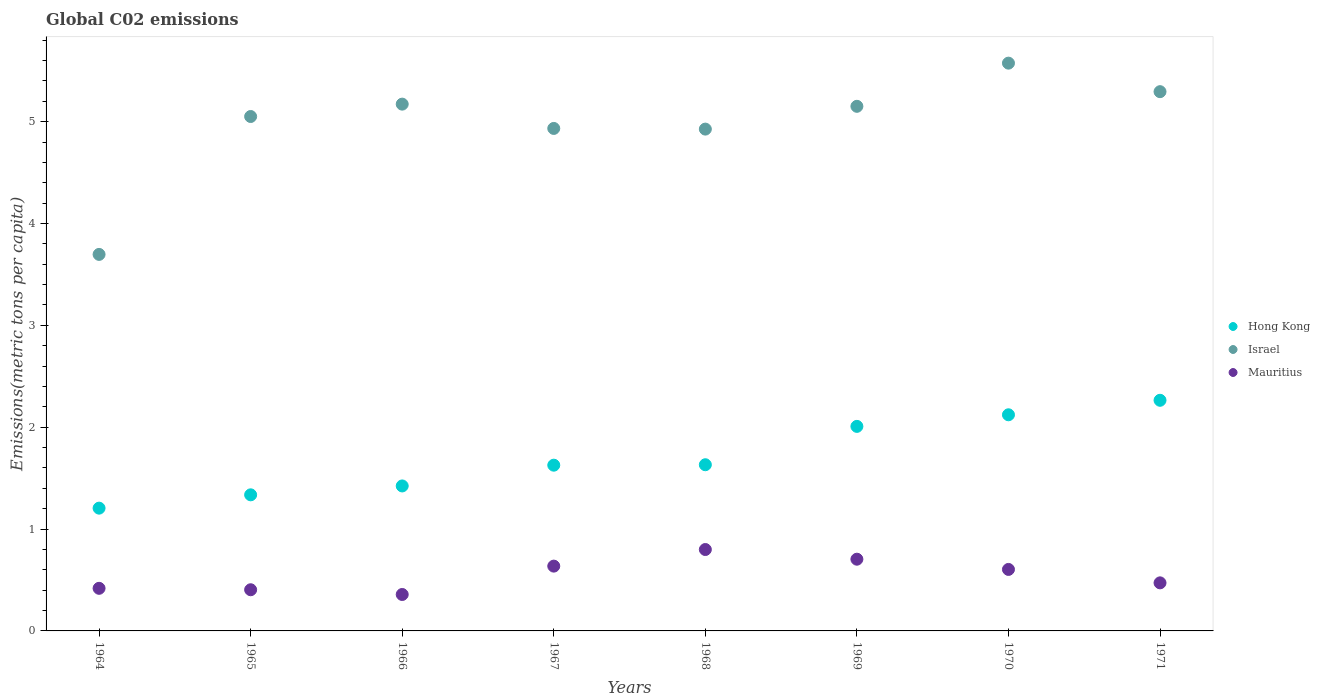How many different coloured dotlines are there?
Keep it short and to the point. 3. Is the number of dotlines equal to the number of legend labels?
Your response must be concise. Yes. What is the amount of CO2 emitted in in Mauritius in 1964?
Make the answer very short. 0.42. Across all years, what is the maximum amount of CO2 emitted in in Hong Kong?
Provide a succinct answer. 2.26. Across all years, what is the minimum amount of CO2 emitted in in Israel?
Offer a very short reply. 3.7. In which year was the amount of CO2 emitted in in Israel minimum?
Offer a terse response. 1964. What is the total amount of CO2 emitted in in Israel in the graph?
Offer a very short reply. 39.8. What is the difference between the amount of CO2 emitted in in Mauritius in 1969 and that in 1970?
Offer a very short reply. 0.1. What is the difference between the amount of CO2 emitted in in Hong Kong in 1966 and the amount of CO2 emitted in in Mauritius in 1971?
Provide a succinct answer. 0.95. What is the average amount of CO2 emitted in in Hong Kong per year?
Ensure brevity in your answer.  1.7. In the year 1968, what is the difference between the amount of CO2 emitted in in Mauritius and amount of CO2 emitted in in Hong Kong?
Your answer should be very brief. -0.83. What is the ratio of the amount of CO2 emitted in in Mauritius in 1968 to that in 1969?
Your answer should be very brief. 1.13. What is the difference between the highest and the second highest amount of CO2 emitted in in Mauritius?
Your response must be concise. 0.1. What is the difference between the highest and the lowest amount of CO2 emitted in in Israel?
Ensure brevity in your answer.  1.88. Is it the case that in every year, the sum of the amount of CO2 emitted in in Israel and amount of CO2 emitted in in Mauritius  is greater than the amount of CO2 emitted in in Hong Kong?
Provide a short and direct response. Yes. Does the amount of CO2 emitted in in Hong Kong monotonically increase over the years?
Offer a very short reply. Yes. Is the amount of CO2 emitted in in Mauritius strictly less than the amount of CO2 emitted in in Hong Kong over the years?
Keep it short and to the point. Yes. How many dotlines are there?
Your response must be concise. 3. How many years are there in the graph?
Keep it short and to the point. 8. Does the graph contain any zero values?
Your answer should be very brief. No. Does the graph contain grids?
Your answer should be very brief. No. Where does the legend appear in the graph?
Your response must be concise. Center right. How many legend labels are there?
Make the answer very short. 3. What is the title of the graph?
Offer a very short reply. Global C02 emissions. Does "Chad" appear as one of the legend labels in the graph?
Offer a very short reply. No. What is the label or title of the X-axis?
Your answer should be very brief. Years. What is the label or title of the Y-axis?
Your answer should be very brief. Emissions(metric tons per capita). What is the Emissions(metric tons per capita) of Hong Kong in 1964?
Your response must be concise. 1.21. What is the Emissions(metric tons per capita) in Israel in 1964?
Provide a succinct answer. 3.7. What is the Emissions(metric tons per capita) of Mauritius in 1964?
Provide a succinct answer. 0.42. What is the Emissions(metric tons per capita) of Hong Kong in 1965?
Your answer should be compact. 1.34. What is the Emissions(metric tons per capita) of Israel in 1965?
Offer a terse response. 5.05. What is the Emissions(metric tons per capita) in Mauritius in 1965?
Make the answer very short. 0.4. What is the Emissions(metric tons per capita) of Hong Kong in 1966?
Offer a very short reply. 1.42. What is the Emissions(metric tons per capita) of Israel in 1966?
Offer a terse response. 5.17. What is the Emissions(metric tons per capita) in Mauritius in 1966?
Offer a very short reply. 0.36. What is the Emissions(metric tons per capita) of Hong Kong in 1967?
Offer a terse response. 1.63. What is the Emissions(metric tons per capita) in Israel in 1967?
Ensure brevity in your answer.  4.93. What is the Emissions(metric tons per capita) in Mauritius in 1967?
Ensure brevity in your answer.  0.64. What is the Emissions(metric tons per capita) in Hong Kong in 1968?
Your answer should be compact. 1.63. What is the Emissions(metric tons per capita) of Israel in 1968?
Provide a short and direct response. 4.93. What is the Emissions(metric tons per capita) of Mauritius in 1968?
Keep it short and to the point. 0.8. What is the Emissions(metric tons per capita) of Hong Kong in 1969?
Offer a terse response. 2.01. What is the Emissions(metric tons per capita) of Israel in 1969?
Offer a very short reply. 5.15. What is the Emissions(metric tons per capita) in Mauritius in 1969?
Make the answer very short. 0.7. What is the Emissions(metric tons per capita) in Hong Kong in 1970?
Make the answer very short. 2.12. What is the Emissions(metric tons per capita) of Israel in 1970?
Ensure brevity in your answer.  5.57. What is the Emissions(metric tons per capita) in Mauritius in 1970?
Offer a terse response. 0.6. What is the Emissions(metric tons per capita) of Hong Kong in 1971?
Make the answer very short. 2.26. What is the Emissions(metric tons per capita) of Israel in 1971?
Keep it short and to the point. 5.29. What is the Emissions(metric tons per capita) in Mauritius in 1971?
Provide a short and direct response. 0.47. Across all years, what is the maximum Emissions(metric tons per capita) in Hong Kong?
Ensure brevity in your answer.  2.26. Across all years, what is the maximum Emissions(metric tons per capita) in Israel?
Provide a short and direct response. 5.57. Across all years, what is the maximum Emissions(metric tons per capita) of Mauritius?
Provide a short and direct response. 0.8. Across all years, what is the minimum Emissions(metric tons per capita) in Hong Kong?
Provide a short and direct response. 1.21. Across all years, what is the minimum Emissions(metric tons per capita) of Israel?
Provide a succinct answer. 3.7. Across all years, what is the minimum Emissions(metric tons per capita) in Mauritius?
Your answer should be very brief. 0.36. What is the total Emissions(metric tons per capita) of Hong Kong in the graph?
Your answer should be very brief. 13.62. What is the total Emissions(metric tons per capita) of Israel in the graph?
Ensure brevity in your answer.  39.8. What is the total Emissions(metric tons per capita) of Mauritius in the graph?
Provide a short and direct response. 4.4. What is the difference between the Emissions(metric tons per capita) in Hong Kong in 1964 and that in 1965?
Offer a terse response. -0.13. What is the difference between the Emissions(metric tons per capita) in Israel in 1964 and that in 1965?
Offer a very short reply. -1.35. What is the difference between the Emissions(metric tons per capita) of Mauritius in 1964 and that in 1965?
Your response must be concise. 0.01. What is the difference between the Emissions(metric tons per capita) of Hong Kong in 1964 and that in 1966?
Ensure brevity in your answer.  -0.22. What is the difference between the Emissions(metric tons per capita) of Israel in 1964 and that in 1966?
Keep it short and to the point. -1.48. What is the difference between the Emissions(metric tons per capita) in Mauritius in 1964 and that in 1966?
Your response must be concise. 0.06. What is the difference between the Emissions(metric tons per capita) in Hong Kong in 1964 and that in 1967?
Provide a short and direct response. -0.42. What is the difference between the Emissions(metric tons per capita) of Israel in 1964 and that in 1967?
Provide a short and direct response. -1.24. What is the difference between the Emissions(metric tons per capita) in Mauritius in 1964 and that in 1967?
Offer a terse response. -0.22. What is the difference between the Emissions(metric tons per capita) of Hong Kong in 1964 and that in 1968?
Give a very brief answer. -0.43. What is the difference between the Emissions(metric tons per capita) of Israel in 1964 and that in 1968?
Give a very brief answer. -1.23. What is the difference between the Emissions(metric tons per capita) in Mauritius in 1964 and that in 1968?
Offer a very short reply. -0.38. What is the difference between the Emissions(metric tons per capita) in Hong Kong in 1964 and that in 1969?
Your answer should be compact. -0.8. What is the difference between the Emissions(metric tons per capita) in Israel in 1964 and that in 1969?
Provide a short and direct response. -1.45. What is the difference between the Emissions(metric tons per capita) in Mauritius in 1964 and that in 1969?
Provide a succinct answer. -0.29. What is the difference between the Emissions(metric tons per capita) of Hong Kong in 1964 and that in 1970?
Your answer should be compact. -0.92. What is the difference between the Emissions(metric tons per capita) of Israel in 1964 and that in 1970?
Offer a very short reply. -1.88. What is the difference between the Emissions(metric tons per capita) of Mauritius in 1964 and that in 1970?
Your response must be concise. -0.19. What is the difference between the Emissions(metric tons per capita) of Hong Kong in 1964 and that in 1971?
Provide a short and direct response. -1.06. What is the difference between the Emissions(metric tons per capita) of Israel in 1964 and that in 1971?
Ensure brevity in your answer.  -1.6. What is the difference between the Emissions(metric tons per capita) of Mauritius in 1964 and that in 1971?
Make the answer very short. -0.05. What is the difference between the Emissions(metric tons per capita) in Hong Kong in 1965 and that in 1966?
Ensure brevity in your answer.  -0.09. What is the difference between the Emissions(metric tons per capita) of Israel in 1965 and that in 1966?
Provide a succinct answer. -0.12. What is the difference between the Emissions(metric tons per capita) of Mauritius in 1965 and that in 1966?
Offer a terse response. 0.05. What is the difference between the Emissions(metric tons per capita) in Hong Kong in 1965 and that in 1967?
Offer a terse response. -0.29. What is the difference between the Emissions(metric tons per capita) in Israel in 1965 and that in 1967?
Your response must be concise. 0.12. What is the difference between the Emissions(metric tons per capita) in Mauritius in 1965 and that in 1967?
Provide a short and direct response. -0.23. What is the difference between the Emissions(metric tons per capita) of Hong Kong in 1965 and that in 1968?
Offer a very short reply. -0.3. What is the difference between the Emissions(metric tons per capita) of Israel in 1965 and that in 1968?
Make the answer very short. 0.12. What is the difference between the Emissions(metric tons per capita) of Mauritius in 1965 and that in 1968?
Your answer should be compact. -0.4. What is the difference between the Emissions(metric tons per capita) of Hong Kong in 1965 and that in 1969?
Give a very brief answer. -0.67. What is the difference between the Emissions(metric tons per capita) in Israel in 1965 and that in 1969?
Give a very brief answer. -0.1. What is the difference between the Emissions(metric tons per capita) of Mauritius in 1965 and that in 1969?
Make the answer very short. -0.3. What is the difference between the Emissions(metric tons per capita) of Hong Kong in 1965 and that in 1970?
Give a very brief answer. -0.79. What is the difference between the Emissions(metric tons per capita) of Israel in 1965 and that in 1970?
Offer a terse response. -0.52. What is the difference between the Emissions(metric tons per capita) in Mauritius in 1965 and that in 1970?
Ensure brevity in your answer.  -0.2. What is the difference between the Emissions(metric tons per capita) of Hong Kong in 1965 and that in 1971?
Your answer should be very brief. -0.93. What is the difference between the Emissions(metric tons per capita) in Israel in 1965 and that in 1971?
Offer a terse response. -0.24. What is the difference between the Emissions(metric tons per capita) of Mauritius in 1965 and that in 1971?
Offer a very short reply. -0.07. What is the difference between the Emissions(metric tons per capita) of Hong Kong in 1966 and that in 1967?
Keep it short and to the point. -0.2. What is the difference between the Emissions(metric tons per capita) in Israel in 1966 and that in 1967?
Provide a succinct answer. 0.24. What is the difference between the Emissions(metric tons per capita) in Mauritius in 1966 and that in 1967?
Offer a very short reply. -0.28. What is the difference between the Emissions(metric tons per capita) in Hong Kong in 1966 and that in 1968?
Keep it short and to the point. -0.21. What is the difference between the Emissions(metric tons per capita) in Israel in 1966 and that in 1968?
Your response must be concise. 0.25. What is the difference between the Emissions(metric tons per capita) of Mauritius in 1966 and that in 1968?
Provide a short and direct response. -0.44. What is the difference between the Emissions(metric tons per capita) of Hong Kong in 1966 and that in 1969?
Your response must be concise. -0.58. What is the difference between the Emissions(metric tons per capita) of Israel in 1966 and that in 1969?
Provide a succinct answer. 0.02. What is the difference between the Emissions(metric tons per capita) in Mauritius in 1966 and that in 1969?
Offer a terse response. -0.35. What is the difference between the Emissions(metric tons per capita) of Hong Kong in 1966 and that in 1970?
Make the answer very short. -0.7. What is the difference between the Emissions(metric tons per capita) in Israel in 1966 and that in 1970?
Offer a very short reply. -0.4. What is the difference between the Emissions(metric tons per capita) of Mauritius in 1966 and that in 1970?
Make the answer very short. -0.25. What is the difference between the Emissions(metric tons per capita) of Hong Kong in 1966 and that in 1971?
Provide a succinct answer. -0.84. What is the difference between the Emissions(metric tons per capita) in Israel in 1966 and that in 1971?
Provide a succinct answer. -0.12. What is the difference between the Emissions(metric tons per capita) of Mauritius in 1966 and that in 1971?
Your answer should be compact. -0.11. What is the difference between the Emissions(metric tons per capita) of Hong Kong in 1967 and that in 1968?
Your answer should be very brief. -0. What is the difference between the Emissions(metric tons per capita) in Israel in 1967 and that in 1968?
Your answer should be compact. 0.01. What is the difference between the Emissions(metric tons per capita) in Mauritius in 1967 and that in 1968?
Your answer should be compact. -0.16. What is the difference between the Emissions(metric tons per capita) of Hong Kong in 1967 and that in 1969?
Give a very brief answer. -0.38. What is the difference between the Emissions(metric tons per capita) of Israel in 1967 and that in 1969?
Offer a very short reply. -0.22. What is the difference between the Emissions(metric tons per capita) in Mauritius in 1967 and that in 1969?
Offer a very short reply. -0.07. What is the difference between the Emissions(metric tons per capita) in Hong Kong in 1967 and that in 1970?
Provide a succinct answer. -0.49. What is the difference between the Emissions(metric tons per capita) of Israel in 1967 and that in 1970?
Your response must be concise. -0.64. What is the difference between the Emissions(metric tons per capita) of Mauritius in 1967 and that in 1970?
Make the answer very short. 0.03. What is the difference between the Emissions(metric tons per capita) of Hong Kong in 1967 and that in 1971?
Make the answer very short. -0.64. What is the difference between the Emissions(metric tons per capita) in Israel in 1967 and that in 1971?
Your answer should be compact. -0.36. What is the difference between the Emissions(metric tons per capita) of Mauritius in 1967 and that in 1971?
Provide a succinct answer. 0.16. What is the difference between the Emissions(metric tons per capita) in Hong Kong in 1968 and that in 1969?
Offer a terse response. -0.38. What is the difference between the Emissions(metric tons per capita) in Israel in 1968 and that in 1969?
Provide a short and direct response. -0.22. What is the difference between the Emissions(metric tons per capita) in Mauritius in 1968 and that in 1969?
Provide a short and direct response. 0.1. What is the difference between the Emissions(metric tons per capita) in Hong Kong in 1968 and that in 1970?
Your answer should be compact. -0.49. What is the difference between the Emissions(metric tons per capita) in Israel in 1968 and that in 1970?
Give a very brief answer. -0.65. What is the difference between the Emissions(metric tons per capita) of Mauritius in 1968 and that in 1970?
Keep it short and to the point. 0.2. What is the difference between the Emissions(metric tons per capita) in Hong Kong in 1968 and that in 1971?
Make the answer very short. -0.63. What is the difference between the Emissions(metric tons per capita) in Israel in 1968 and that in 1971?
Your answer should be very brief. -0.37. What is the difference between the Emissions(metric tons per capita) of Mauritius in 1968 and that in 1971?
Ensure brevity in your answer.  0.33. What is the difference between the Emissions(metric tons per capita) of Hong Kong in 1969 and that in 1970?
Ensure brevity in your answer.  -0.11. What is the difference between the Emissions(metric tons per capita) in Israel in 1969 and that in 1970?
Your response must be concise. -0.42. What is the difference between the Emissions(metric tons per capita) of Mauritius in 1969 and that in 1970?
Your answer should be very brief. 0.1. What is the difference between the Emissions(metric tons per capita) of Hong Kong in 1969 and that in 1971?
Offer a terse response. -0.26. What is the difference between the Emissions(metric tons per capita) in Israel in 1969 and that in 1971?
Make the answer very short. -0.14. What is the difference between the Emissions(metric tons per capita) of Mauritius in 1969 and that in 1971?
Offer a very short reply. 0.23. What is the difference between the Emissions(metric tons per capita) in Hong Kong in 1970 and that in 1971?
Offer a very short reply. -0.14. What is the difference between the Emissions(metric tons per capita) in Israel in 1970 and that in 1971?
Give a very brief answer. 0.28. What is the difference between the Emissions(metric tons per capita) in Mauritius in 1970 and that in 1971?
Offer a terse response. 0.13. What is the difference between the Emissions(metric tons per capita) of Hong Kong in 1964 and the Emissions(metric tons per capita) of Israel in 1965?
Your response must be concise. -3.85. What is the difference between the Emissions(metric tons per capita) of Hong Kong in 1964 and the Emissions(metric tons per capita) of Mauritius in 1965?
Provide a succinct answer. 0.8. What is the difference between the Emissions(metric tons per capita) of Israel in 1964 and the Emissions(metric tons per capita) of Mauritius in 1965?
Make the answer very short. 3.29. What is the difference between the Emissions(metric tons per capita) of Hong Kong in 1964 and the Emissions(metric tons per capita) of Israel in 1966?
Provide a short and direct response. -3.97. What is the difference between the Emissions(metric tons per capita) in Hong Kong in 1964 and the Emissions(metric tons per capita) in Mauritius in 1966?
Provide a succinct answer. 0.85. What is the difference between the Emissions(metric tons per capita) in Israel in 1964 and the Emissions(metric tons per capita) in Mauritius in 1966?
Your response must be concise. 3.34. What is the difference between the Emissions(metric tons per capita) of Hong Kong in 1964 and the Emissions(metric tons per capita) of Israel in 1967?
Your response must be concise. -3.73. What is the difference between the Emissions(metric tons per capita) of Hong Kong in 1964 and the Emissions(metric tons per capita) of Mauritius in 1967?
Provide a short and direct response. 0.57. What is the difference between the Emissions(metric tons per capita) in Israel in 1964 and the Emissions(metric tons per capita) in Mauritius in 1967?
Offer a terse response. 3.06. What is the difference between the Emissions(metric tons per capita) in Hong Kong in 1964 and the Emissions(metric tons per capita) in Israel in 1968?
Offer a very short reply. -3.72. What is the difference between the Emissions(metric tons per capita) in Hong Kong in 1964 and the Emissions(metric tons per capita) in Mauritius in 1968?
Ensure brevity in your answer.  0.41. What is the difference between the Emissions(metric tons per capita) in Israel in 1964 and the Emissions(metric tons per capita) in Mauritius in 1968?
Make the answer very short. 2.9. What is the difference between the Emissions(metric tons per capita) of Hong Kong in 1964 and the Emissions(metric tons per capita) of Israel in 1969?
Give a very brief answer. -3.95. What is the difference between the Emissions(metric tons per capita) of Hong Kong in 1964 and the Emissions(metric tons per capita) of Mauritius in 1969?
Give a very brief answer. 0.5. What is the difference between the Emissions(metric tons per capita) in Israel in 1964 and the Emissions(metric tons per capita) in Mauritius in 1969?
Make the answer very short. 2.99. What is the difference between the Emissions(metric tons per capita) in Hong Kong in 1964 and the Emissions(metric tons per capita) in Israel in 1970?
Your response must be concise. -4.37. What is the difference between the Emissions(metric tons per capita) in Hong Kong in 1964 and the Emissions(metric tons per capita) in Mauritius in 1970?
Keep it short and to the point. 0.6. What is the difference between the Emissions(metric tons per capita) of Israel in 1964 and the Emissions(metric tons per capita) of Mauritius in 1970?
Make the answer very short. 3.09. What is the difference between the Emissions(metric tons per capita) in Hong Kong in 1964 and the Emissions(metric tons per capita) in Israel in 1971?
Ensure brevity in your answer.  -4.09. What is the difference between the Emissions(metric tons per capita) of Hong Kong in 1964 and the Emissions(metric tons per capita) of Mauritius in 1971?
Make the answer very short. 0.73. What is the difference between the Emissions(metric tons per capita) of Israel in 1964 and the Emissions(metric tons per capita) of Mauritius in 1971?
Provide a succinct answer. 3.22. What is the difference between the Emissions(metric tons per capita) in Hong Kong in 1965 and the Emissions(metric tons per capita) in Israel in 1966?
Offer a very short reply. -3.84. What is the difference between the Emissions(metric tons per capita) of Hong Kong in 1965 and the Emissions(metric tons per capita) of Mauritius in 1966?
Provide a succinct answer. 0.98. What is the difference between the Emissions(metric tons per capita) of Israel in 1965 and the Emissions(metric tons per capita) of Mauritius in 1966?
Make the answer very short. 4.69. What is the difference between the Emissions(metric tons per capita) of Hong Kong in 1965 and the Emissions(metric tons per capita) of Israel in 1967?
Provide a short and direct response. -3.6. What is the difference between the Emissions(metric tons per capita) of Israel in 1965 and the Emissions(metric tons per capita) of Mauritius in 1967?
Provide a short and direct response. 4.41. What is the difference between the Emissions(metric tons per capita) of Hong Kong in 1965 and the Emissions(metric tons per capita) of Israel in 1968?
Your answer should be very brief. -3.59. What is the difference between the Emissions(metric tons per capita) in Hong Kong in 1965 and the Emissions(metric tons per capita) in Mauritius in 1968?
Make the answer very short. 0.54. What is the difference between the Emissions(metric tons per capita) of Israel in 1965 and the Emissions(metric tons per capita) of Mauritius in 1968?
Give a very brief answer. 4.25. What is the difference between the Emissions(metric tons per capita) in Hong Kong in 1965 and the Emissions(metric tons per capita) in Israel in 1969?
Provide a short and direct response. -3.81. What is the difference between the Emissions(metric tons per capita) in Hong Kong in 1965 and the Emissions(metric tons per capita) in Mauritius in 1969?
Make the answer very short. 0.63. What is the difference between the Emissions(metric tons per capita) of Israel in 1965 and the Emissions(metric tons per capita) of Mauritius in 1969?
Provide a short and direct response. 4.35. What is the difference between the Emissions(metric tons per capita) of Hong Kong in 1965 and the Emissions(metric tons per capita) of Israel in 1970?
Offer a terse response. -4.24. What is the difference between the Emissions(metric tons per capita) in Hong Kong in 1965 and the Emissions(metric tons per capita) in Mauritius in 1970?
Your answer should be very brief. 0.73. What is the difference between the Emissions(metric tons per capita) in Israel in 1965 and the Emissions(metric tons per capita) in Mauritius in 1970?
Offer a very short reply. 4.45. What is the difference between the Emissions(metric tons per capita) in Hong Kong in 1965 and the Emissions(metric tons per capita) in Israel in 1971?
Provide a short and direct response. -3.96. What is the difference between the Emissions(metric tons per capita) of Hong Kong in 1965 and the Emissions(metric tons per capita) of Mauritius in 1971?
Your response must be concise. 0.86. What is the difference between the Emissions(metric tons per capita) in Israel in 1965 and the Emissions(metric tons per capita) in Mauritius in 1971?
Your answer should be compact. 4.58. What is the difference between the Emissions(metric tons per capita) of Hong Kong in 1966 and the Emissions(metric tons per capita) of Israel in 1967?
Provide a succinct answer. -3.51. What is the difference between the Emissions(metric tons per capita) of Hong Kong in 1966 and the Emissions(metric tons per capita) of Mauritius in 1967?
Your answer should be very brief. 0.79. What is the difference between the Emissions(metric tons per capita) of Israel in 1966 and the Emissions(metric tons per capita) of Mauritius in 1967?
Provide a short and direct response. 4.54. What is the difference between the Emissions(metric tons per capita) of Hong Kong in 1966 and the Emissions(metric tons per capita) of Israel in 1968?
Give a very brief answer. -3.5. What is the difference between the Emissions(metric tons per capita) of Hong Kong in 1966 and the Emissions(metric tons per capita) of Mauritius in 1968?
Keep it short and to the point. 0.62. What is the difference between the Emissions(metric tons per capita) in Israel in 1966 and the Emissions(metric tons per capita) in Mauritius in 1968?
Offer a very short reply. 4.37. What is the difference between the Emissions(metric tons per capita) in Hong Kong in 1966 and the Emissions(metric tons per capita) in Israel in 1969?
Offer a very short reply. -3.73. What is the difference between the Emissions(metric tons per capita) of Hong Kong in 1966 and the Emissions(metric tons per capita) of Mauritius in 1969?
Give a very brief answer. 0.72. What is the difference between the Emissions(metric tons per capita) of Israel in 1966 and the Emissions(metric tons per capita) of Mauritius in 1969?
Your response must be concise. 4.47. What is the difference between the Emissions(metric tons per capita) in Hong Kong in 1966 and the Emissions(metric tons per capita) in Israel in 1970?
Your answer should be compact. -4.15. What is the difference between the Emissions(metric tons per capita) of Hong Kong in 1966 and the Emissions(metric tons per capita) of Mauritius in 1970?
Offer a terse response. 0.82. What is the difference between the Emissions(metric tons per capita) of Israel in 1966 and the Emissions(metric tons per capita) of Mauritius in 1970?
Ensure brevity in your answer.  4.57. What is the difference between the Emissions(metric tons per capita) in Hong Kong in 1966 and the Emissions(metric tons per capita) in Israel in 1971?
Give a very brief answer. -3.87. What is the difference between the Emissions(metric tons per capita) of Hong Kong in 1966 and the Emissions(metric tons per capita) of Mauritius in 1971?
Provide a short and direct response. 0.95. What is the difference between the Emissions(metric tons per capita) of Israel in 1966 and the Emissions(metric tons per capita) of Mauritius in 1971?
Offer a very short reply. 4.7. What is the difference between the Emissions(metric tons per capita) in Hong Kong in 1967 and the Emissions(metric tons per capita) in Israel in 1968?
Offer a terse response. -3.3. What is the difference between the Emissions(metric tons per capita) in Hong Kong in 1967 and the Emissions(metric tons per capita) in Mauritius in 1968?
Give a very brief answer. 0.83. What is the difference between the Emissions(metric tons per capita) of Israel in 1967 and the Emissions(metric tons per capita) of Mauritius in 1968?
Give a very brief answer. 4.13. What is the difference between the Emissions(metric tons per capita) in Hong Kong in 1967 and the Emissions(metric tons per capita) in Israel in 1969?
Give a very brief answer. -3.52. What is the difference between the Emissions(metric tons per capita) of Hong Kong in 1967 and the Emissions(metric tons per capita) of Mauritius in 1969?
Your answer should be very brief. 0.92. What is the difference between the Emissions(metric tons per capita) in Israel in 1967 and the Emissions(metric tons per capita) in Mauritius in 1969?
Make the answer very short. 4.23. What is the difference between the Emissions(metric tons per capita) in Hong Kong in 1967 and the Emissions(metric tons per capita) in Israel in 1970?
Keep it short and to the point. -3.95. What is the difference between the Emissions(metric tons per capita) of Hong Kong in 1967 and the Emissions(metric tons per capita) of Mauritius in 1970?
Provide a succinct answer. 1.02. What is the difference between the Emissions(metric tons per capita) in Israel in 1967 and the Emissions(metric tons per capita) in Mauritius in 1970?
Keep it short and to the point. 4.33. What is the difference between the Emissions(metric tons per capita) in Hong Kong in 1967 and the Emissions(metric tons per capita) in Israel in 1971?
Offer a terse response. -3.67. What is the difference between the Emissions(metric tons per capita) of Hong Kong in 1967 and the Emissions(metric tons per capita) of Mauritius in 1971?
Provide a succinct answer. 1.16. What is the difference between the Emissions(metric tons per capita) of Israel in 1967 and the Emissions(metric tons per capita) of Mauritius in 1971?
Keep it short and to the point. 4.46. What is the difference between the Emissions(metric tons per capita) in Hong Kong in 1968 and the Emissions(metric tons per capita) in Israel in 1969?
Give a very brief answer. -3.52. What is the difference between the Emissions(metric tons per capita) of Hong Kong in 1968 and the Emissions(metric tons per capita) of Mauritius in 1969?
Your response must be concise. 0.93. What is the difference between the Emissions(metric tons per capita) of Israel in 1968 and the Emissions(metric tons per capita) of Mauritius in 1969?
Your answer should be compact. 4.22. What is the difference between the Emissions(metric tons per capita) in Hong Kong in 1968 and the Emissions(metric tons per capita) in Israel in 1970?
Keep it short and to the point. -3.94. What is the difference between the Emissions(metric tons per capita) of Hong Kong in 1968 and the Emissions(metric tons per capita) of Mauritius in 1970?
Ensure brevity in your answer.  1.03. What is the difference between the Emissions(metric tons per capita) of Israel in 1968 and the Emissions(metric tons per capita) of Mauritius in 1970?
Ensure brevity in your answer.  4.32. What is the difference between the Emissions(metric tons per capita) in Hong Kong in 1968 and the Emissions(metric tons per capita) in Israel in 1971?
Provide a short and direct response. -3.66. What is the difference between the Emissions(metric tons per capita) in Hong Kong in 1968 and the Emissions(metric tons per capita) in Mauritius in 1971?
Offer a very short reply. 1.16. What is the difference between the Emissions(metric tons per capita) in Israel in 1968 and the Emissions(metric tons per capita) in Mauritius in 1971?
Your response must be concise. 4.45. What is the difference between the Emissions(metric tons per capita) of Hong Kong in 1969 and the Emissions(metric tons per capita) of Israel in 1970?
Ensure brevity in your answer.  -3.57. What is the difference between the Emissions(metric tons per capita) of Hong Kong in 1969 and the Emissions(metric tons per capita) of Mauritius in 1970?
Provide a short and direct response. 1.4. What is the difference between the Emissions(metric tons per capita) of Israel in 1969 and the Emissions(metric tons per capita) of Mauritius in 1970?
Ensure brevity in your answer.  4.55. What is the difference between the Emissions(metric tons per capita) in Hong Kong in 1969 and the Emissions(metric tons per capita) in Israel in 1971?
Offer a very short reply. -3.29. What is the difference between the Emissions(metric tons per capita) in Hong Kong in 1969 and the Emissions(metric tons per capita) in Mauritius in 1971?
Offer a terse response. 1.54. What is the difference between the Emissions(metric tons per capita) in Israel in 1969 and the Emissions(metric tons per capita) in Mauritius in 1971?
Ensure brevity in your answer.  4.68. What is the difference between the Emissions(metric tons per capita) of Hong Kong in 1970 and the Emissions(metric tons per capita) of Israel in 1971?
Ensure brevity in your answer.  -3.17. What is the difference between the Emissions(metric tons per capita) in Hong Kong in 1970 and the Emissions(metric tons per capita) in Mauritius in 1971?
Your answer should be very brief. 1.65. What is the difference between the Emissions(metric tons per capita) of Israel in 1970 and the Emissions(metric tons per capita) of Mauritius in 1971?
Keep it short and to the point. 5.1. What is the average Emissions(metric tons per capita) of Hong Kong per year?
Give a very brief answer. 1.7. What is the average Emissions(metric tons per capita) of Israel per year?
Keep it short and to the point. 4.97. What is the average Emissions(metric tons per capita) of Mauritius per year?
Your response must be concise. 0.55. In the year 1964, what is the difference between the Emissions(metric tons per capita) of Hong Kong and Emissions(metric tons per capita) of Israel?
Ensure brevity in your answer.  -2.49. In the year 1964, what is the difference between the Emissions(metric tons per capita) of Hong Kong and Emissions(metric tons per capita) of Mauritius?
Make the answer very short. 0.79. In the year 1964, what is the difference between the Emissions(metric tons per capita) in Israel and Emissions(metric tons per capita) in Mauritius?
Offer a terse response. 3.28. In the year 1965, what is the difference between the Emissions(metric tons per capita) of Hong Kong and Emissions(metric tons per capita) of Israel?
Ensure brevity in your answer.  -3.71. In the year 1965, what is the difference between the Emissions(metric tons per capita) of Hong Kong and Emissions(metric tons per capita) of Mauritius?
Ensure brevity in your answer.  0.93. In the year 1965, what is the difference between the Emissions(metric tons per capita) of Israel and Emissions(metric tons per capita) of Mauritius?
Your answer should be very brief. 4.65. In the year 1966, what is the difference between the Emissions(metric tons per capita) in Hong Kong and Emissions(metric tons per capita) in Israel?
Provide a succinct answer. -3.75. In the year 1966, what is the difference between the Emissions(metric tons per capita) of Hong Kong and Emissions(metric tons per capita) of Mauritius?
Your answer should be compact. 1.07. In the year 1966, what is the difference between the Emissions(metric tons per capita) in Israel and Emissions(metric tons per capita) in Mauritius?
Provide a succinct answer. 4.81. In the year 1967, what is the difference between the Emissions(metric tons per capita) of Hong Kong and Emissions(metric tons per capita) of Israel?
Your response must be concise. -3.31. In the year 1967, what is the difference between the Emissions(metric tons per capita) of Israel and Emissions(metric tons per capita) of Mauritius?
Make the answer very short. 4.3. In the year 1968, what is the difference between the Emissions(metric tons per capita) of Hong Kong and Emissions(metric tons per capita) of Israel?
Offer a terse response. -3.3. In the year 1968, what is the difference between the Emissions(metric tons per capita) in Hong Kong and Emissions(metric tons per capita) in Mauritius?
Offer a very short reply. 0.83. In the year 1968, what is the difference between the Emissions(metric tons per capita) of Israel and Emissions(metric tons per capita) of Mauritius?
Give a very brief answer. 4.13. In the year 1969, what is the difference between the Emissions(metric tons per capita) of Hong Kong and Emissions(metric tons per capita) of Israel?
Your response must be concise. -3.14. In the year 1969, what is the difference between the Emissions(metric tons per capita) in Hong Kong and Emissions(metric tons per capita) in Mauritius?
Provide a short and direct response. 1.3. In the year 1969, what is the difference between the Emissions(metric tons per capita) of Israel and Emissions(metric tons per capita) of Mauritius?
Your answer should be compact. 4.45. In the year 1970, what is the difference between the Emissions(metric tons per capita) of Hong Kong and Emissions(metric tons per capita) of Israel?
Make the answer very short. -3.45. In the year 1970, what is the difference between the Emissions(metric tons per capita) in Hong Kong and Emissions(metric tons per capita) in Mauritius?
Keep it short and to the point. 1.52. In the year 1970, what is the difference between the Emissions(metric tons per capita) in Israel and Emissions(metric tons per capita) in Mauritius?
Offer a very short reply. 4.97. In the year 1971, what is the difference between the Emissions(metric tons per capita) of Hong Kong and Emissions(metric tons per capita) of Israel?
Offer a terse response. -3.03. In the year 1971, what is the difference between the Emissions(metric tons per capita) in Hong Kong and Emissions(metric tons per capita) in Mauritius?
Keep it short and to the point. 1.79. In the year 1971, what is the difference between the Emissions(metric tons per capita) in Israel and Emissions(metric tons per capita) in Mauritius?
Make the answer very short. 4.82. What is the ratio of the Emissions(metric tons per capita) of Hong Kong in 1964 to that in 1965?
Your answer should be compact. 0.9. What is the ratio of the Emissions(metric tons per capita) of Israel in 1964 to that in 1965?
Provide a succinct answer. 0.73. What is the ratio of the Emissions(metric tons per capita) in Mauritius in 1964 to that in 1965?
Provide a succinct answer. 1.03. What is the ratio of the Emissions(metric tons per capita) in Hong Kong in 1964 to that in 1966?
Offer a terse response. 0.85. What is the ratio of the Emissions(metric tons per capita) of Israel in 1964 to that in 1966?
Ensure brevity in your answer.  0.71. What is the ratio of the Emissions(metric tons per capita) of Mauritius in 1964 to that in 1966?
Keep it short and to the point. 1.17. What is the ratio of the Emissions(metric tons per capita) of Hong Kong in 1964 to that in 1967?
Provide a succinct answer. 0.74. What is the ratio of the Emissions(metric tons per capita) of Israel in 1964 to that in 1967?
Offer a terse response. 0.75. What is the ratio of the Emissions(metric tons per capita) of Mauritius in 1964 to that in 1967?
Ensure brevity in your answer.  0.66. What is the ratio of the Emissions(metric tons per capita) of Hong Kong in 1964 to that in 1968?
Your answer should be compact. 0.74. What is the ratio of the Emissions(metric tons per capita) in Israel in 1964 to that in 1968?
Your answer should be compact. 0.75. What is the ratio of the Emissions(metric tons per capita) in Mauritius in 1964 to that in 1968?
Your response must be concise. 0.52. What is the ratio of the Emissions(metric tons per capita) of Hong Kong in 1964 to that in 1969?
Your answer should be very brief. 0.6. What is the ratio of the Emissions(metric tons per capita) of Israel in 1964 to that in 1969?
Make the answer very short. 0.72. What is the ratio of the Emissions(metric tons per capita) of Mauritius in 1964 to that in 1969?
Make the answer very short. 0.59. What is the ratio of the Emissions(metric tons per capita) in Hong Kong in 1964 to that in 1970?
Offer a terse response. 0.57. What is the ratio of the Emissions(metric tons per capita) in Israel in 1964 to that in 1970?
Offer a very short reply. 0.66. What is the ratio of the Emissions(metric tons per capita) in Mauritius in 1964 to that in 1970?
Your response must be concise. 0.69. What is the ratio of the Emissions(metric tons per capita) of Hong Kong in 1964 to that in 1971?
Ensure brevity in your answer.  0.53. What is the ratio of the Emissions(metric tons per capita) in Israel in 1964 to that in 1971?
Provide a short and direct response. 0.7. What is the ratio of the Emissions(metric tons per capita) in Mauritius in 1964 to that in 1971?
Your answer should be very brief. 0.89. What is the ratio of the Emissions(metric tons per capita) in Hong Kong in 1965 to that in 1966?
Your answer should be very brief. 0.94. What is the ratio of the Emissions(metric tons per capita) of Israel in 1965 to that in 1966?
Offer a terse response. 0.98. What is the ratio of the Emissions(metric tons per capita) in Mauritius in 1965 to that in 1966?
Your answer should be very brief. 1.13. What is the ratio of the Emissions(metric tons per capita) in Hong Kong in 1965 to that in 1967?
Keep it short and to the point. 0.82. What is the ratio of the Emissions(metric tons per capita) of Israel in 1965 to that in 1967?
Offer a very short reply. 1.02. What is the ratio of the Emissions(metric tons per capita) in Mauritius in 1965 to that in 1967?
Provide a succinct answer. 0.64. What is the ratio of the Emissions(metric tons per capita) in Hong Kong in 1965 to that in 1968?
Your answer should be compact. 0.82. What is the ratio of the Emissions(metric tons per capita) of Israel in 1965 to that in 1968?
Offer a terse response. 1.03. What is the ratio of the Emissions(metric tons per capita) in Mauritius in 1965 to that in 1968?
Make the answer very short. 0.51. What is the ratio of the Emissions(metric tons per capita) of Hong Kong in 1965 to that in 1969?
Your answer should be compact. 0.67. What is the ratio of the Emissions(metric tons per capita) in Israel in 1965 to that in 1969?
Offer a terse response. 0.98. What is the ratio of the Emissions(metric tons per capita) in Mauritius in 1965 to that in 1969?
Your answer should be compact. 0.57. What is the ratio of the Emissions(metric tons per capita) in Hong Kong in 1965 to that in 1970?
Give a very brief answer. 0.63. What is the ratio of the Emissions(metric tons per capita) of Israel in 1965 to that in 1970?
Ensure brevity in your answer.  0.91. What is the ratio of the Emissions(metric tons per capita) in Mauritius in 1965 to that in 1970?
Your answer should be very brief. 0.67. What is the ratio of the Emissions(metric tons per capita) of Hong Kong in 1965 to that in 1971?
Make the answer very short. 0.59. What is the ratio of the Emissions(metric tons per capita) of Israel in 1965 to that in 1971?
Ensure brevity in your answer.  0.95. What is the ratio of the Emissions(metric tons per capita) of Mauritius in 1965 to that in 1971?
Give a very brief answer. 0.86. What is the ratio of the Emissions(metric tons per capita) of Hong Kong in 1966 to that in 1967?
Keep it short and to the point. 0.87. What is the ratio of the Emissions(metric tons per capita) in Israel in 1966 to that in 1967?
Give a very brief answer. 1.05. What is the ratio of the Emissions(metric tons per capita) in Mauritius in 1966 to that in 1967?
Keep it short and to the point. 0.56. What is the ratio of the Emissions(metric tons per capita) of Hong Kong in 1966 to that in 1968?
Your response must be concise. 0.87. What is the ratio of the Emissions(metric tons per capita) of Israel in 1966 to that in 1968?
Your response must be concise. 1.05. What is the ratio of the Emissions(metric tons per capita) in Mauritius in 1966 to that in 1968?
Make the answer very short. 0.45. What is the ratio of the Emissions(metric tons per capita) in Hong Kong in 1966 to that in 1969?
Offer a terse response. 0.71. What is the ratio of the Emissions(metric tons per capita) of Israel in 1966 to that in 1969?
Ensure brevity in your answer.  1. What is the ratio of the Emissions(metric tons per capita) in Mauritius in 1966 to that in 1969?
Your answer should be very brief. 0.51. What is the ratio of the Emissions(metric tons per capita) of Hong Kong in 1966 to that in 1970?
Your answer should be very brief. 0.67. What is the ratio of the Emissions(metric tons per capita) in Israel in 1966 to that in 1970?
Offer a very short reply. 0.93. What is the ratio of the Emissions(metric tons per capita) in Mauritius in 1966 to that in 1970?
Your answer should be compact. 0.59. What is the ratio of the Emissions(metric tons per capita) of Hong Kong in 1966 to that in 1971?
Offer a terse response. 0.63. What is the ratio of the Emissions(metric tons per capita) of Israel in 1966 to that in 1971?
Offer a terse response. 0.98. What is the ratio of the Emissions(metric tons per capita) of Mauritius in 1966 to that in 1971?
Your answer should be very brief. 0.76. What is the ratio of the Emissions(metric tons per capita) in Mauritius in 1967 to that in 1968?
Offer a very short reply. 0.8. What is the ratio of the Emissions(metric tons per capita) in Hong Kong in 1967 to that in 1969?
Give a very brief answer. 0.81. What is the ratio of the Emissions(metric tons per capita) in Israel in 1967 to that in 1969?
Offer a very short reply. 0.96. What is the ratio of the Emissions(metric tons per capita) of Mauritius in 1967 to that in 1969?
Provide a succinct answer. 0.9. What is the ratio of the Emissions(metric tons per capita) of Hong Kong in 1967 to that in 1970?
Ensure brevity in your answer.  0.77. What is the ratio of the Emissions(metric tons per capita) of Israel in 1967 to that in 1970?
Your answer should be very brief. 0.89. What is the ratio of the Emissions(metric tons per capita) of Mauritius in 1967 to that in 1970?
Provide a short and direct response. 1.05. What is the ratio of the Emissions(metric tons per capita) in Hong Kong in 1967 to that in 1971?
Give a very brief answer. 0.72. What is the ratio of the Emissions(metric tons per capita) of Israel in 1967 to that in 1971?
Offer a terse response. 0.93. What is the ratio of the Emissions(metric tons per capita) of Mauritius in 1967 to that in 1971?
Your answer should be compact. 1.35. What is the ratio of the Emissions(metric tons per capita) in Hong Kong in 1968 to that in 1969?
Make the answer very short. 0.81. What is the ratio of the Emissions(metric tons per capita) in Israel in 1968 to that in 1969?
Ensure brevity in your answer.  0.96. What is the ratio of the Emissions(metric tons per capita) of Mauritius in 1968 to that in 1969?
Provide a short and direct response. 1.13. What is the ratio of the Emissions(metric tons per capita) in Hong Kong in 1968 to that in 1970?
Make the answer very short. 0.77. What is the ratio of the Emissions(metric tons per capita) of Israel in 1968 to that in 1970?
Offer a terse response. 0.88. What is the ratio of the Emissions(metric tons per capita) in Mauritius in 1968 to that in 1970?
Your answer should be very brief. 1.32. What is the ratio of the Emissions(metric tons per capita) of Hong Kong in 1968 to that in 1971?
Your answer should be very brief. 0.72. What is the ratio of the Emissions(metric tons per capita) of Israel in 1968 to that in 1971?
Give a very brief answer. 0.93. What is the ratio of the Emissions(metric tons per capita) of Mauritius in 1968 to that in 1971?
Give a very brief answer. 1.69. What is the ratio of the Emissions(metric tons per capita) of Hong Kong in 1969 to that in 1970?
Keep it short and to the point. 0.95. What is the ratio of the Emissions(metric tons per capita) in Israel in 1969 to that in 1970?
Your answer should be compact. 0.92. What is the ratio of the Emissions(metric tons per capita) of Mauritius in 1969 to that in 1970?
Your response must be concise. 1.17. What is the ratio of the Emissions(metric tons per capita) in Hong Kong in 1969 to that in 1971?
Give a very brief answer. 0.89. What is the ratio of the Emissions(metric tons per capita) of Israel in 1969 to that in 1971?
Offer a very short reply. 0.97. What is the ratio of the Emissions(metric tons per capita) in Mauritius in 1969 to that in 1971?
Provide a short and direct response. 1.49. What is the ratio of the Emissions(metric tons per capita) of Hong Kong in 1970 to that in 1971?
Provide a succinct answer. 0.94. What is the ratio of the Emissions(metric tons per capita) of Israel in 1970 to that in 1971?
Ensure brevity in your answer.  1.05. What is the ratio of the Emissions(metric tons per capita) in Mauritius in 1970 to that in 1971?
Provide a succinct answer. 1.28. What is the difference between the highest and the second highest Emissions(metric tons per capita) of Hong Kong?
Keep it short and to the point. 0.14. What is the difference between the highest and the second highest Emissions(metric tons per capita) of Israel?
Keep it short and to the point. 0.28. What is the difference between the highest and the second highest Emissions(metric tons per capita) in Mauritius?
Offer a very short reply. 0.1. What is the difference between the highest and the lowest Emissions(metric tons per capita) in Hong Kong?
Your answer should be compact. 1.06. What is the difference between the highest and the lowest Emissions(metric tons per capita) in Israel?
Your answer should be very brief. 1.88. What is the difference between the highest and the lowest Emissions(metric tons per capita) of Mauritius?
Ensure brevity in your answer.  0.44. 